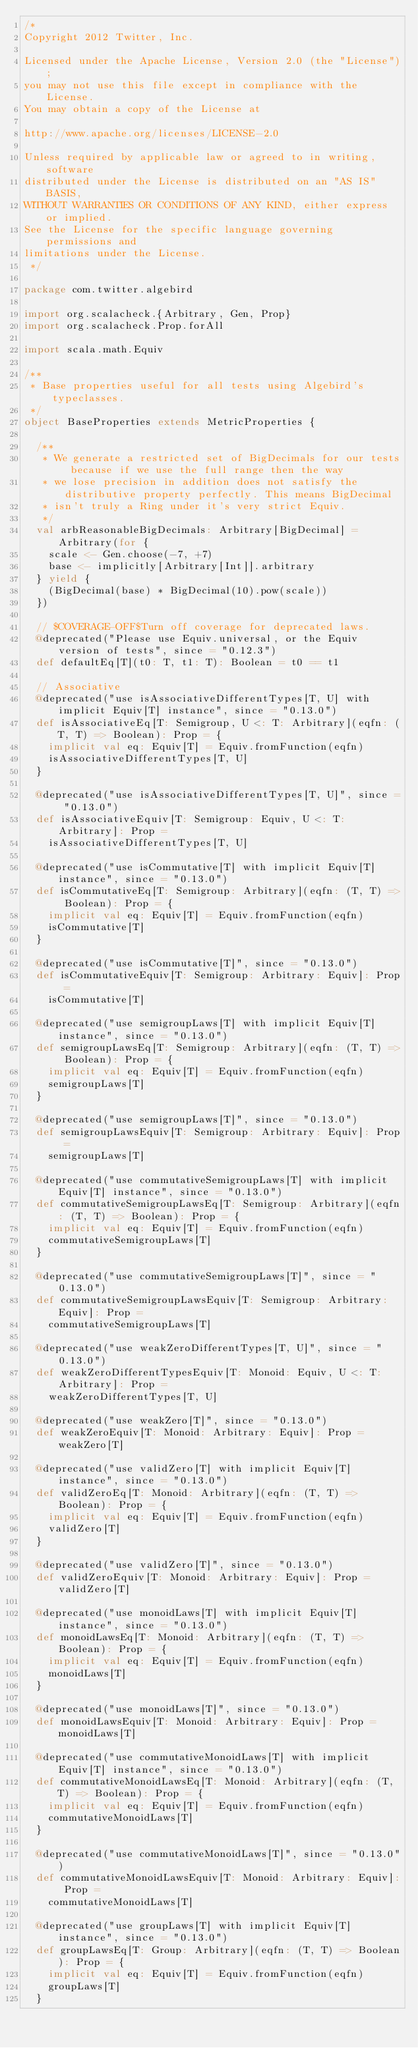<code> <loc_0><loc_0><loc_500><loc_500><_Scala_>/*
Copyright 2012 Twitter, Inc.

Licensed under the Apache License, Version 2.0 (the "License");
you may not use this file except in compliance with the License.
You may obtain a copy of the License at

http://www.apache.org/licenses/LICENSE-2.0

Unless required by applicable law or agreed to in writing, software
distributed under the License is distributed on an "AS IS" BASIS,
WITHOUT WARRANTIES OR CONDITIONS OF ANY KIND, either express or implied.
See the License for the specific language governing permissions and
limitations under the License.
 */

package com.twitter.algebird

import org.scalacheck.{Arbitrary, Gen, Prop}
import org.scalacheck.Prop.forAll

import scala.math.Equiv

/**
 * Base properties useful for all tests using Algebird's typeclasses.
 */
object BaseProperties extends MetricProperties {

  /**
   * We generate a restricted set of BigDecimals for our tests because if we use the full range then the way
   * we lose precision in addition does not satisfy the distributive property perfectly. This means BigDecimal
   * isn't truly a Ring under it's very strict Equiv.
   */
  val arbReasonableBigDecimals: Arbitrary[BigDecimal] = Arbitrary(for {
    scale <- Gen.choose(-7, +7)
    base <- implicitly[Arbitrary[Int]].arbitrary
  } yield {
    (BigDecimal(base) * BigDecimal(10).pow(scale))
  })

  // $COVERAGE-OFF$Turn off coverage for deprecated laws.
  @deprecated("Please use Equiv.universal, or the Equiv version of tests", since = "0.12.3")
  def defaultEq[T](t0: T, t1: T): Boolean = t0 == t1

  // Associative
  @deprecated("use isAssociativeDifferentTypes[T, U] with implicit Equiv[T] instance", since = "0.13.0")
  def isAssociativeEq[T: Semigroup, U <: T: Arbitrary](eqfn: (T, T) => Boolean): Prop = {
    implicit val eq: Equiv[T] = Equiv.fromFunction(eqfn)
    isAssociativeDifferentTypes[T, U]
  }

  @deprecated("use isAssociativeDifferentTypes[T, U]", since = "0.13.0")
  def isAssociativeEquiv[T: Semigroup: Equiv, U <: T: Arbitrary]: Prop =
    isAssociativeDifferentTypes[T, U]

  @deprecated("use isCommutative[T] with implicit Equiv[T] instance", since = "0.13.0")
  def isCommutativeEq[T: Semigroup: Arbitrary](eqfn: (T, T) => Boolean): Prop = {
    implicit val eq: Equiv[T] = Equiv.fromFunction(eqfn)
    isCommutative[T]
  }

  @deprecated("use isCommutative[T]", since = "0.13.0")
  def isCommutativeEquiv[T: Semigroup: Arbitrary: Equiv]: Prop =
    isCommutative[T]

  @deprecated("use semigroupLaws[T] with implicit Equiv[T] instance", since = "0.13.0")
  def semigroupLawsEq[T: Semigroup: Arbitrary](eqfn: (T, T) => Boolean): Prop = {
    implicit val eq: Equiv[T] = Equiv.fromFunction(eqfn)
    semigroupLaws[T]
  }

  @deprecated("use semigroupLaws[T]", since = "0.13.0")
  def semigroupLawsEquiv[T: Semigroup: Arbitrary: Equiv]: Prop =
    semigroupLaws[T]

  @deprecated("use commutativeSemigroupLaws[T] with implicit Equiv[T] instance", since = "0.13.0")
  def commutativeSemigroupLawsEq[T: Semigroup: Arbitrary](eqfn: (T, T) => Boolean): Prop = {
    implicit val eq: Equiv[T] = Equiv.fromFunction(eqfn)
    commutativeSemigroupLaws[T]
  }

  @deprecated("use commutativeSemigroupLaws[T]", since = "0.13.0")
  def commutativeSemigroupLawsEquiv[T: Semigroup: Arbitrary: Equiv]: Prop =
    commutativeSemigroupLaws[T]

  @deprecated("use weakZeroDifferentTypes[T, U]", since = "0.13.0")
  def weakZeroDifferentTypesEquiv[T: Monoid: Equiv, U <: T: Arbitrary]: Prop =
    weakZeroDifferentTypes[T, U]

  @deprecated("use weakZero[T]", since = "0.13.0")
  def weakZeroEquiv[T: Monoid: Arbitrary: Equiv]: Prop = weakZero[T]

  @deprecated("use validZero[T] with implicit Equiv[T] instance", since = "0.13.0")
  def validZeroEq[T: Monoid: Arbitrary](eqfn: (T, T) => Boolean): Prop = {
    implicit val eq: Equiv[T] = Equiv.fromFunction(eqfn)
    validZero[T]
  }

  @deprecated("use validZero[T]", since = "0.13.0")
  def validZeroEquiv[T: Monoid: Arbitrary: Equiv]: Prop = validZero[T]

  @deprecated("use monoidLaws[T] with implicit Equiv[T] instance", since = "0.13.0")
  def monoidLawsEq[T: Monoid: Arbitrary](eqfn: (T, T) => Boolean): Prop = {
    implicit val eq: Equiv[T] = Equiv.fromFunction(eqfn)
    monoidLaws[T]
  }

  @deprecated("use monoidLaws[T]", since = "0.13.0")
  def monoidLawsEquiv[T: Monoid: Arbitrary: Equiv]: Prop = monoidLaws[T]

  @deprecated("use commutativeMonoidLaws[T] with implicit Equiv[T] instance", since = "0.13.0")
  def commutativeMonoidLawsEq[T: Monoid: Arbitrary](eqfn: (T, T) => Boolean): Prop = {
    implicit val eq: Equiv[T] = Equiv.fromFunction(eqfn)
    commutativeMonoidLaws[T]
  }

  @deprecated("use commutativeMonoidLaws[T]", since = "0.13.0")
  def commutativeMonoidLawsEquiv[T: Monoid: Arbitrary: Equiv]: Prop =
    commutativeMonoidLaws[T]

  @deprecated("use groupLaws[T] with implicit Equiv[T] instance", since = "0.13.0")
  def groupLawsEq[T: Group: Arbitrary](eqfn: (T, T) => Boolean): Prop = {
    implicit val eq: Equiv[T] = Equiv.fromFunction(eqfn)
    groupLaws[T]
  }
</code> 